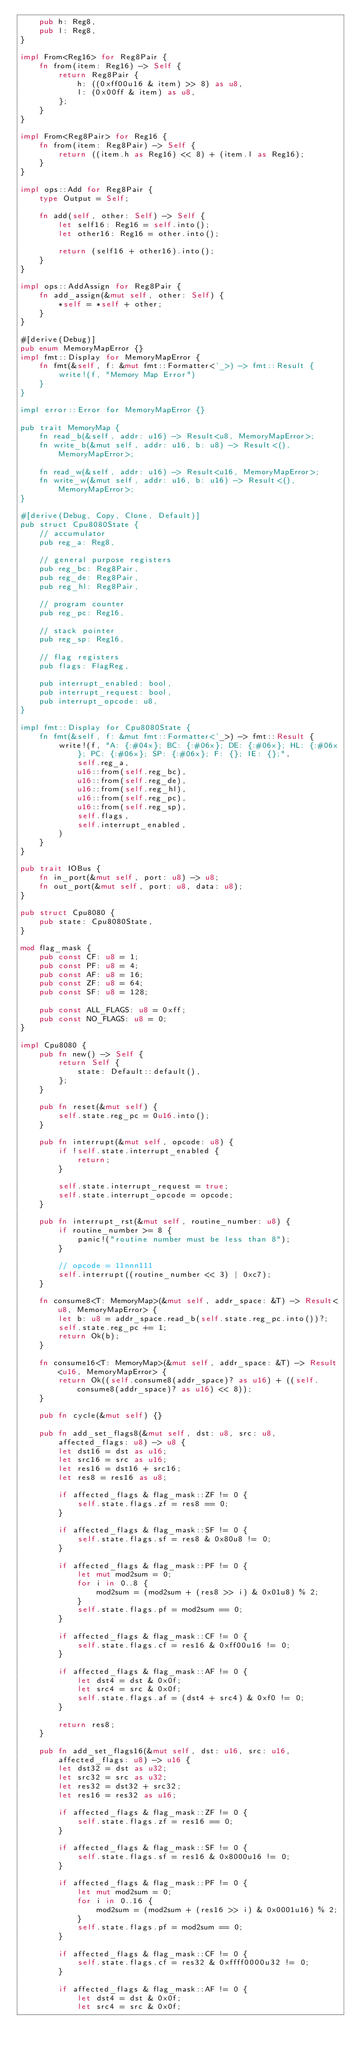Convert code to text. <code><loc_0><loc_0><loc_500><loc_500><_Rust_>    pub h: Reg8,
    pub l: Reg8,
}

impl From<Reg16> for Reg8Pair {
    fn from(item: Reg16) -> Self {
        return Reg8Pair {
            h: ((0xff00u16 & item) >> 8) as u8,
            l: (0x00ff & item) as u8,
        };
    }
}

impl From<Reg8Pair> for Reg16 {
    fn from(item: Reg8Pair) -> Self {
        return ((item.h as Reg16) << 8) + (item.l as Reg16);
    }
}

impl ops::Add for Reg8Pair {
    type Output = Self;

    fn add(self, other: Self) -> Self {
        let self16: Reg16 = self.into();
        let other16: Reg16 = other.into();

        return (self16 + other16).into();
    }
}

impl ops::AddAssign for Reg8Pair {
    fn add_assign(&mut self, other: Self) {
        *self = *self + other;
    }
}

#[derive(Debug)]
pub enum MemoryMapError {}
impl fmt::Display for MemoryMapError {
    fn fmt(&self, f: &mut fmt::Formatter<'_>) -> fmt::Result {
        write!(f, "Memory Map Error")
    }
}

impl error::Error for MemoryMapError {}

pub trait MemoryMap {
    fn read_b(&self, addr: u16) -> Result<u8, MemoryMapError>;
    fn write_b(&mut self, addr: u16, b: u8) -> Result<(), MemoryMapError>;

    fn read_w(&self, addr: u16) -> Result<u16, MemoryMapError>;
    fn write_w(&mut self, addr: u16, b: u16) -> Result<(), MemoryMapError>;
}

#[derive(Debug, Copy, Clone, Default)]
pub struct Cpu8080State {
    // accumulator
    pub reg_a: Reg8,

    // general purpose registers
    pub reg_bc: Reg8Pair,
    pub reg_de: Reg8Pair,
    pub reg_hl: Reg8Pair,

    // program counter
    pub reg_pc: Reg16,

    // stack pointer
    pub reg_sp: Reg16,

    // flag registers
    pub flags: FlagReg,

    pub interrupt_enabled: bool,
    pub interrupt_request: bool,
    pub interrupt_opcode: u8,
}

impl fmt::Display for Cpu8080State {
    fn fmt(&self, f: &mut fmt::Formatter<'_>) -> fmt::Result {
        write!(f, "A: {:#04x}; BC: {:#06x}; DE: {:#06x}; HL: {:#06x}; PC: {:#06x}; SP: {:#06x}; F: {}; IE: {};",
            self.reg_a,
            u16::from(self.reg_bc),
            u16::from(self.reg_de),
            u16::from(self.reg_hl),
            u16::from(self.reg_pc),
            u16::from(self.reg_sp),
            self.flags,
            self.interrupt_enabled,
        )
    }
}

pub trait IOBus {
    fn in_port(&mut self, port: u8) -> u8;
    fn out_port(&mut self, port: u8, data: u8);
}

pub struct Cpu8080 {
    pub state: Cpu8080State,
}

mod flag_mask {
    pub const CF: u8 = 1;
    pub const PF: u8 = 4;
    pub const AF: u8 = 16;
    pub const ZF: u8 = 64;
    pub const SF: u8 = 128;

    pub const ALL_FLAGS: u8 = 0xff;
    pub const NO_FLAGS: u8 = 0;
}

impl Cpu8080 {
    pub fn new() -> Self {
        return Self {
            state: Default::default(),
        };
    }

    pub fn reset(&mut self) {
        self.state.reg_pc = 0u16.into();
    }

    pub fn interrupt(&mut self, opcode: u8) {
        if !self.state.interrupt_enabled {
            return;
        }
        
        self.state.interrupt_request = true;
        self.state.interrupt_opcode = opcode;
    }

    pub fn interrupt_rst(&mut self, routine_number: u8) {
        if routine_number >= 8 {
            panic!("routine number must be less than 8");
        }

        // opcode = 11nnn111
        self.interrupt((routine_number << 3) | 0xc7);
    }

    fn consume8<T: MemoryMap>(&mut self, addr_space: &T) -> Result<u8, MemoryMapError> {
        let b: u8 = addr_space.read_b(self.state.reg_pc.into())?;
        self.state.reg_pc += 1;
        return Ok(b);
    }

    fn consume16<T: MemoryMap>(&mut self, addr_space: &T) -> Result<u16, MemoryMapError> {
        return Ok((self.consume8(addr_space)? as u16) + ((self.consume8(addr_space)? as u16) << 8));
    }

    pub fn cycle(&mut self) {}

    pub fn add_set_flags8(&mut self, dst: u8, src: u8, affected_flags: u8) -> u8 {
        let dst16 = dst as u16;
        let src16 = src as u16;
        let res16 = dst16 + src16;
        let res8 = res16 as u8;

        if affected_flags & flag_mask::ZF != 0 {
            self.state.flags.zf = res8 == 0;
        }

        if affected_flags & flag_mask::SF != 0 {
            self.state.flags.sf = res8 & 0x80u8 != 0;
        }

        if affected_flags & flag_mask::PF != 0 {
            let mut mod2sum = 0;
            for i in 0..8 {
                mod2sum = (mod2sum + (res8 >> i) & 0x01u8) % 2;
            }
            self.state.flags.pf = mod2sum == 0;
        }

        if affected_flags & flag_mask::CF != 0 {
            self.state.flags.cf = res16 & 0xff00u16 != 0;
        }

        if affected_flags & flag_mask::AF != 0 {
            let dst4 = dst & 0x0f;
            let src4 = src & 0x0f;
            self.state.flags.af = (dst4 + src4) & 0xf0 != 0;
        }

        return res8;
    }

    pub fn add_set_flags16(&mut self, dst: u16, src: u16, affected_flags: u8) -> u16 {
        let dst32 = dst as u32;
        let src32 = src as u32;
        let res32 = dst32 + src32;
        let res16 = res32 as u16;

        if affected_flags & flag_mask::ZF != 0 {
            self.state.flags.zf = res16 == 0;
        }

        if affected_flags & flag_mask::SF != 0 {
            self.state.flags.sf = res16 & 0x8000u16 != 0;
        }

        if affected_flags & flag_mask::PF != 0 {
            let mut mod2sum = 0;
            for i in 0..16 {
                mod2sum = (mod2sum + (res16 >> i) & 0x0001u16) % 2;
            }
            self.state.flags.pf = mod2sum == 0;
        }

        if affected_flags & flag_mask::CF != 0 {
            self.state.flags.cf = res32 & 0xffff0000u32 != 0;
        }

        if affected_flags & flag_mask::AF != 0 {
            let dst4 = dst & 0x0f;
            let src4 = src & 0x0f;</code> 